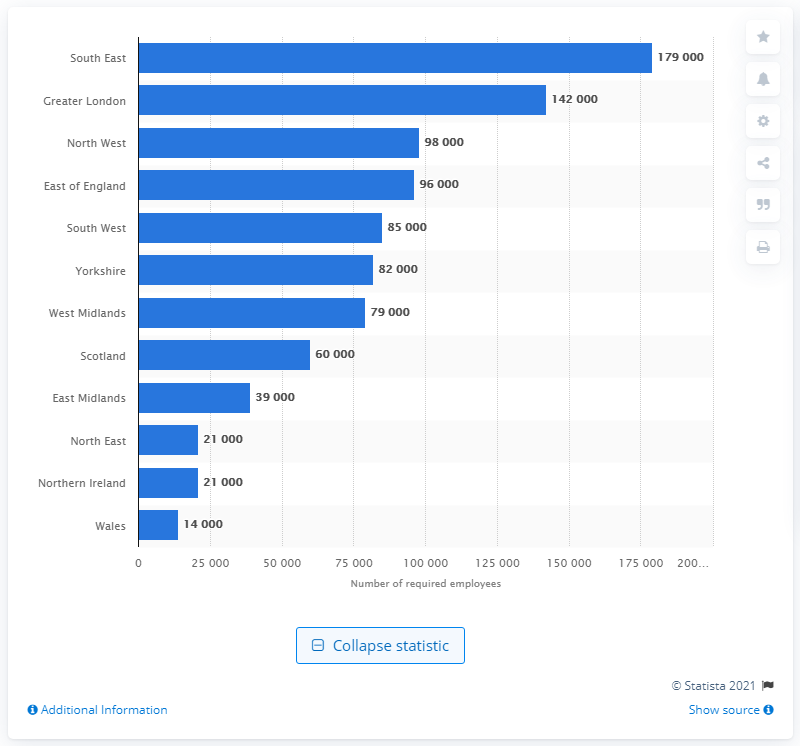Outline some significant characteristics in this image. By 2020, it is expected that the logistics industry will require approximately 179,000 new employees to meet the increasing demand for transportation and logistics services. An estimated 60,000 people will be required in the logistics industry in Scotland by 2020 to meet the growing demand for transport and distribution services. 